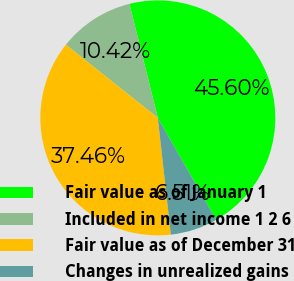Convert chart. <chart><loc_0><loc_0><loc_500><loc_500><pie_chart><fcel>Fair value as of January 1<fcel>Included in net income 1 2 6<fcel>Fair value as of December 31<fcel>Changes in unrealized gains<nl><fcel>45.6%<fcel>10.42%<fcel>37.46%<fcel>6.51%<nl></chart> 